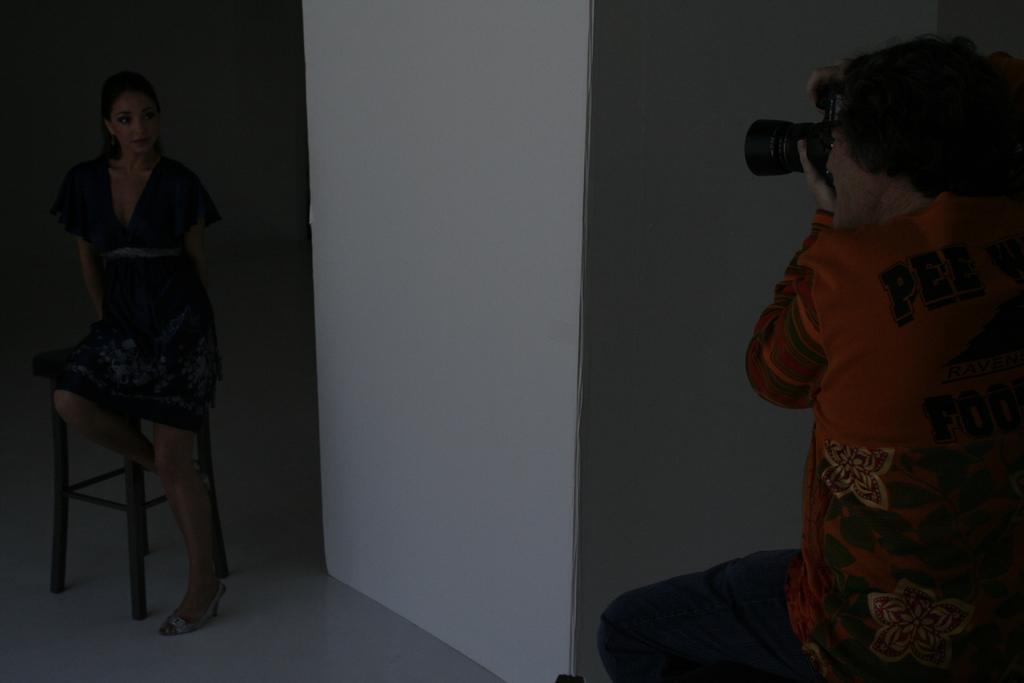How would you summarize this image in a sentence or two? There is a lady and a stool on the left side of the image and there is a man on the right side holding a camera in his hands. There is a wall in the center. 